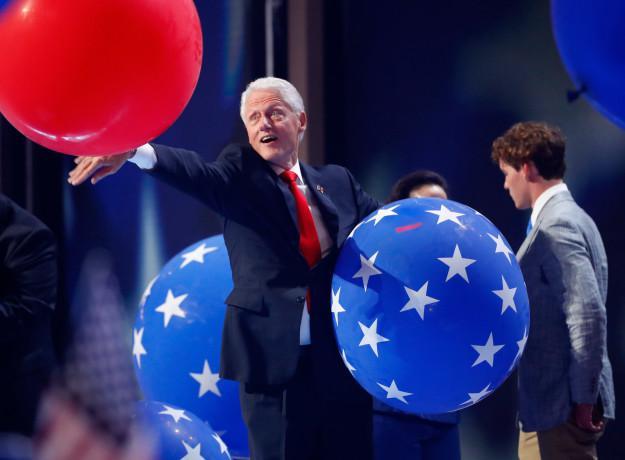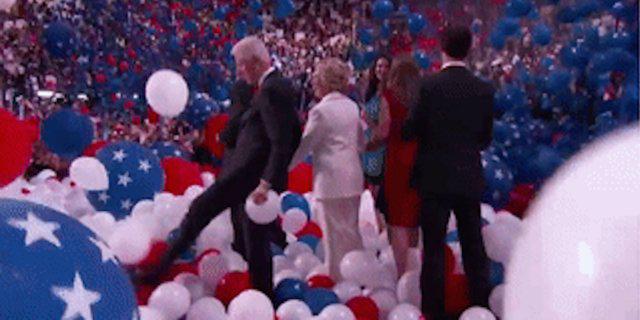The first image is the image on the left, the second image is the image on the right. Given the left and right images, does the statement "A white haired man is playing with red, white and blue balloons." hold true? Answer yes or no. Yes. 